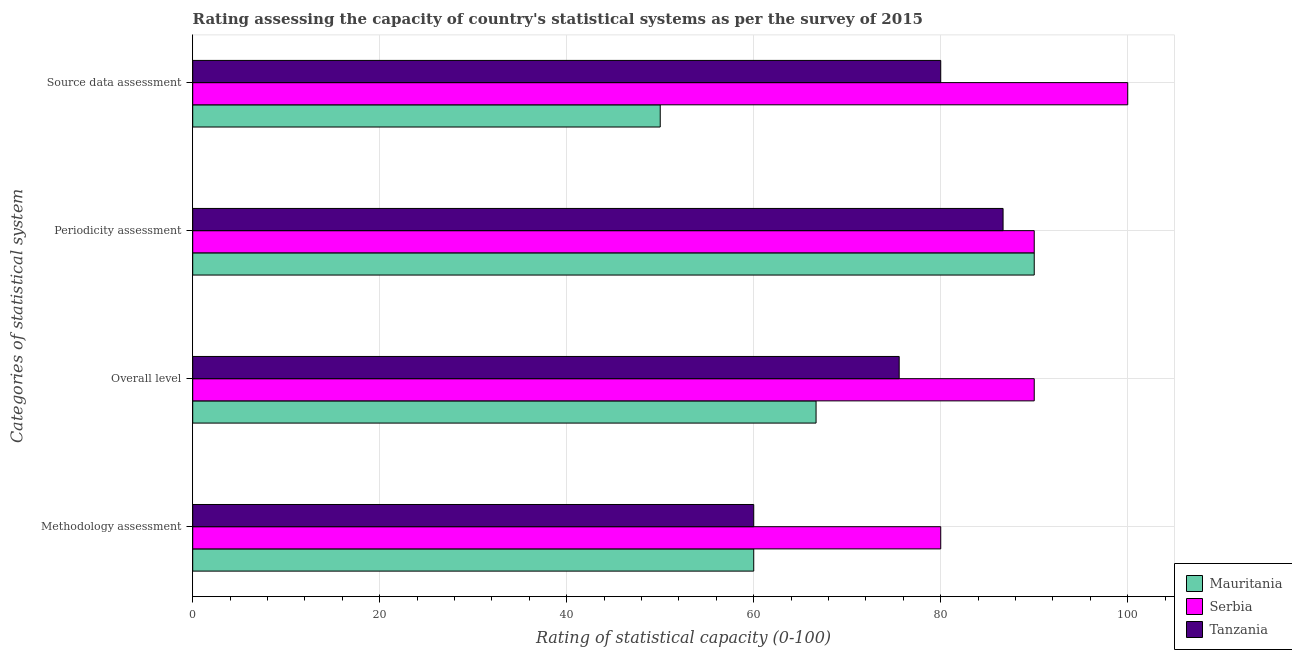How many different coloured bars are there?
Ensure brevity in your answer.  3. How many groups of bars are there?
Provide a succinct answer. 4. Are the number of bars on each tick of the Y-axis equal?
Make the answer very short. Yes. How many bars are there on the 4th tick from the top?
Make the answer very short. 3. How many bars are there on the 2nd tick from the bottom?
Offer a terse response. 3. What is the label of the 3rd group of bars from the top?
Give a very brief answer. Overall level. What is the overall level rating in Tanzania?
Ensure brevity in your answer.  75.56. Across all countries, what is the minimum source data assessment rating?
Provide a short and direct response. 50. In which country was the overall level rating maximum?
Provide a succinct answer. Serbia. In which country was the periodicity assessment rating minimum?
Your response must be concise. Tanzania. What is the total periodicity assessment rating in the graph?
Keep it short and to the point. 266.67. What is the difference between the overall level rating in Serbia and that in Tanzania?
Ensure brevity in your answer.  14.44. What is the average overall level rating per country?
Your response must be concise. 77.41. What is the difference between the overall level rating and source data assessment rating in Mauritania?
Ensure brevity in your answer.  16.67. In how many countries, is the source data assessment rating greater than 28 ?
Ensure brevity in your answer.  3. Is the methodology assessment rating in Serbia less than that in Tanzania?
Give a very brief answer. No. Is the difference between the periodicity assessment rating in Tanzania and Mauritania greater than the difference between the methodology assessment rating in Tanzania and Mauritania?
Make the answer very short. No. What is the difference between the highest and the lowest overall level rating?
Your answer should be very brief. 23.33. In how many countries, is the overall level rating greater than the average overall level rating taken over all countries?
Your answer should be very brief. 1. Is the sum of the source data assessment rating in Mauritania and Tanzania greater than the maximum methodology assessment rating across all countries?
Your response must be concise. Yes. Is it the case that in every country, the sum of the periodicity assessment rating and overall level rating is greater than the sum of methodology assessment rating and source data assessment rating?
Your answer should be compact. Yes. What does the 2nd bar from the top in Periodicity assessment represents?
Give a very brief answer. Serbia. What does the 1st bar from the bottom in Overall level represents?
Your answer should be very brief. Mauritania. How many bars are there?
Make the answer very short. 12. Are all the bars in the graph horizontal?
Ensure brevity in your answer.  Yes. Are the values on the major ticks of X-axis written in scientific E-notation?
Your response must be concise. No. Does the graph contain grids?
Provide a succinct answer. Yes. Where does the legend appear in the graph?
Offer a terse response. Bottom right. How many legend labels are there?
Make the answer very short. 3. What is the title of the graph?
Provide a succinct answer. Rating assessing the capacity of country's statistical systems as per the survey of 2015 . Does "Turkmenistan" appear as one of the legend labels in the graph?
Ensure brevity in your answer.  No. What is the label or title of the X-axis?
Provide a short and direct response. Rating of statistical capacity (0-100). What is the label or title of the Y-axis?
Your answer should be very brief. Categories of statistical system. What is the Rating of statistical capacity (0-100) of Mauritania in Methodology assessment?
Ensure brevity in your answer.  60. What is the Rating of statistical capacity (0-100) of Mauritania in Overall level?
Ensure brevity in your answer.  66.67. What is the Rating of statistical capacity (0-100) of Tanzania in Overall level?
Keep it short and to the point. 75.56. What is the Rating of statistical capacity (0-100) of Mauritania in Periodicity assessment?
Provide a succinct answer. 90. What is the Rating of statistical capacity (0-100) of Serbia in Periodicity assessment?
Provide a succinct answer. 90. What is the Rating of statistical capacity (0-100) in Tanzania in Periodicity assessment?
Your answer should be compact. 86.67. What is the Rating of statistical capacity (0-100) in Mauritania in Source data assessment?
Provide a succinct answer. 50. What is the Rating of statistical capacity (0-100) of Serbia in Source data assessment?
Offer a very short reply. 100. Across all Categories of statistical system, what is the maximum Rating of statistical capacity (0-100) of Mauritania?
Ensure brevity in your answer.  90. Across all Categories of statistical system, what is the maximum Rating of statistical capacity (0-100) in Tanzania?
Provide a short and direct response. 86.67. Across all Categories of statistical system, what is the minimum Rating of statistical capacity (0-100) in Serbia?
Provide a succinct answer. 80. What is the total Rating of statistical capacity (0-100) in Mauritania in the graph?
Give a very brief answer. 266.67. What is the total Rating of statistical capacity (0-100) of Serbia in the graph?
Provide a succinct answer. 360. What is the total Rating of statistical capacity (0-100) of Tanzania in the graph?
Give a very brief answer. 302.22. What is the difference between the Rating of statistical capacity (0-100) of Mauritania in Methodology assessment and that in Overall level?
Your answer should be very brief. -6.67. What is the difference between the Rating of statistical capacity (0-100) of Serbia in Methodology assessment and that in Overall level?
Offer a very short reply. -10. What is the difference between the Rating of statistical capacity (0-100) in Tanzania in Methodology assessment and that in Overall level?
Provide a short and direct response. -15.56. What is the difference between the Rating of statistical capacity (0-100) of Mauritania in Methodology assessment and that in Periodicity assessment?
Offer a very short reply. -30. What is the difference between the Rating of statistical capacity (0-100) of Serbia in Methodology assessment and that in Periodicity assessment?
Make the answer very short. -10. What is the difference between the Rating of statistical capacity (0-100) of Tanzania in Methodology assessment and that in Periodicity assessment?
Ensure brevity in your answer.  -26.67. What is the difference between the Rating of statistical capacity (0-100) in Serbia in Methodology assessment and that in Source data assessment?
Provide a succinct answer. -20. What is the difference between the Rating of statistical capacity (0-100) of Mauritania in Overall level and that in Periodicity assessment?
Give a very brief answer. -23.33. What is the difference between the Rating of statistical capacity (0-100) in Tanzania in Overall level and that in Periodicity assessment?
Ensure brevity in your answer.  -11.11. What is the difference between the Rating of statistical capacity (0-100) of Mauritania in Overall level and that in Source data assessment?
Your answer should be very brief. 16.67. What is the difference between the Rating of statistical capacity (0-100) of Serbia in Overall level and that in Source data assessment?
Provide a succinct answer. -10. What is the difference between the Rating of statistical capacity (0-100) in Tanzania in Overall level and that in Source data assessment?
Give a very brief answer. -4.44. What is the difference between the Rating of statistical capacity (0-100) of Mauritania in Periodicity assessment and that in Source data assessment?
Give a very brief answer. 40. What is the difference between the Rating of statistical capacity (0-100) in Tanzania in Periodicity assessment and that in Source data assessment?
Give a very brief answer. 6.67. What is the difference between the Rating of statistical capacity (0-100) in Mauritania in Methodology assessment and the Rating of statistical capacity (0-100) in Serbia in Overall level?
Your response must be concise. -30. What is the difference between the Rating of statistical capacity (0-100) of Mauritania in Methodology assessment and the Rating of statistical capacity (0-100) of Tanzania in Overall level?
Ensure brevity in your answer.  -15.56. What is the difference between the Rating of statistical capacity (0-100) in Serbia in Methodology assessment and the Rating of statistical capacity (0-100) in Tanzania in Overall level?
Give a very brief answer. 4.44. What is the difference between the Rating of statistical capacity (0-100) of Mauritania in Methodology assessment and the Rating of statistical capacity (0-100) of Serbia in Periodicity assessment?
Give a very brief answer. -30. What is the difference between the Rating of statistical capacity (0-100) of Mauritania in Methodology assessment and the Rating of statistical capacity (0-100) of Tanzania in Periodicity assessment?
Provide a short and direct response. -26.67. What is the difference between the Rating of statistical capacity (0-100) of Serbia in Methodology assessment and the Rating of statistical capacity (0-100) of Tanzania in Periodicity assessment?
Offer a very short reply. -6.67. What is the difference between the Rating of statistical capacity (0-100) in Mauritania in Methodology assessment and the Rating of statistical capacity (0-100) in Serbia in Source data assessment?
Ensure brevity in your answer.  -40. What is the difference between the Rating of statistical capacity (0-100) of Mauritania in Methodology assessment and the Rating of statistical capacity (0-100) of Tanzania in Source data assessment?
Provide a short and direct response. -20. What is the difference between the Rating of statistical capacity (0-100) in Serbia in Methodology assessment and the Rating of statistical capacity (0-100) in Tanzania in Source data assessment?
Provide a short and direct response. 0. What is the difference between the Rating of statistical capacity (0-100) in Mauritania in Overall level and the Rating of statistical capacity (0-100) in Serbia in Periodicity assessment?
Your response must be concise. -23.33. What is the difference between the Rating of statistical capacity (0-100) of Mauritania in Overall level and the Rating of statistical capacity (0-100) of Tanzania in Periodicity assessment?
Keep it short and to the point. -20. What is the difference between the Rating of statistical capacity (0-100) of Serbia in Overall level and the Rating of statistical capacity (0-100) of Tanzania in Periodicity assessment?
Ensure brevity in your answer.  3.33. What is the difference between the Rating of statistical capacity (0-100) of Mauritania in Overall level and the Rating of statistical capacity (0-100) of Serbia in Source data assessment?
Offer a very short reply. -33.33. What is the difference between the Rating of statistical capacity (0-100) of Mauritania in Overall level and the Rating of statistical capacity (0-100) of Tanzania in Source data assessment?
Your answer should be compact. -13.33. What is the difference between the Rating of statistical capacity (0-100) of Mauritania in Periodicity assessment and the Rating of statistical capacity (0-100) of Serbia in Source data assessment?
Ensure brevity in your answer.  -10. What is the difference between the Rating of statistical capacity (0-100) of Mauritania in Periodicity assessment and the Rating of statistical capacity (0-100) of Tanzania in Source data assessment?
Provide a succinct answer. 10. What is the difference between the Rating of statistical capacity (0-100) in Serbia in Periodicity assessment and the Rating of statistical capacity (0-100) in Tanzania in Source data assessment?
Provide a short and direct response. 10. What is the average Rating of statistical capacity (0-100) in Mauritania per Categories of statistical system?
Your answer should be compact. 66.67. What is the average Rating of statistical capacity (0-100) in Serbia per Categories of statistical system?
Keep it short and to the point. 90. What is the average Rating of statistical capacity (0-100) in Tanzania per Categories of statistical system?
Your response must be concise. 75.56. What is the difference between the Rating of statistical capacity (0-100) in Serbia and Rating of statistical capacity (0-100) in Tanzania in Methodology assessment?
Provide a succinct answer. 20. What is the difference between the Rating of statistical capacity (0-100) of Mauritania and Rating of statistical capacity (0-100) of Serbia in Overall level?
Offer a very short reply. -23.33. What is the difference between the Rating of statistical capacity (0-100) in Mauritania and Rating of statistical capacity (0-100) in Tanzania in Overall level?
Offer a very short reply. -8.89. What is the difference between the Rating of statistical capacity (0-100) in Serbia and Rating of statistical capacity (0-100) in Tanzania in Overall level?
Your answer should be compact. 14.44. What is the difference between the Rating of statistical capacity (0-100) in Mauritania and Rating of statistical capacity (0-100) in Serbia in Periodicity assessment?
Your response must be concise. 0. What is the difference between the Rating of statistical capacity (0-100) of Mauritania and Rating of statistical capacity (0-100) of Tanzania in Periodicity assessment?
Your answer should be very brief. 3.33. What is the difference between the Rating of statistical capacity (0-100) of Serbia and Rating of statistical capacity (0-100) of Tanzania in Periodicity assessment?
Your answer should be very brief. 3.33. What is the difference between the Rating of statistical capacity (0-100) of Mauritania and Rating of statistical capacity (0-100) of Serbia in Source data assessment?
Ensure brevity in your answer.  -50. What is the difference between the Rating of statistical capacity (0-100) in Serbia and Rating of statistical capacity (0-100) in Tanzania in Source data assessment?
Your answer should be very brief. 20. What is the ratio of the Rating of statistical capacity (0-100) of Mauritania in Methodology assessment to that in Overall level?
Your response must be concise. 0.9. What is the ratio of the Rating of statistical capacity (0-100) in Serbia in Methodology assessment to that in Overall level?
Your answer should be compact. 0.89. What is the ratio of the Rating of statistical capacity (0-100) in Tanzania in Methodology assessment to that in Overall level?
Make the answer very short. 0.79. What is the ratio of the Rating of statistical capacity (0-100) in Serbia in Methodology assessment to that in Periodicity assessment?
Offer a very short reply. 0.89. What is the ratio of the Rating of statistical capacity (0-100) in Tanzania in Methodology assessment to that in Periodicity assessment?
Give a very brief answer. 0.69. What is the ratio of the Rating of statistical capacity (0-100) in Serbia in Methodology assessment to that in Source data assessment?
Offer a very short reply. 0.8. What is the ratio of the Rating of statistical capacity (0-100) in Mauritania in Overall level to that in Periodicity assessment?
Your answer should be very brief. 0.74. What is the ratio of the Rating of statistical capacity (0-100) in Serbia in Overall level to that in Periodicity assessment?
Your answer should be compact. 1. What is the ratio of the Rating of statistical capacity (0-100) of Tanzania in Overall level to that in Periodicity assessment?
Keep it short and to the point. 0.87. What is the ratio of the Rating of statistical capacity (0-100) of Mauritania in Periodicity assessment to that in Source data assessment?
Give a very brief answer. 1.8. What is the ratio of the Rating of statistical capacity (0-100) of Serbia in Periodicity assessment to that in Source data assessment?
Make the answer very short. 0.9. What is the difference between the highest and the second highest Rating of statistical capacity (0-100) of Mauritania?
Offer a terse response. 23.33. What is the difference between the highest and the second highest Rating of statistical capacity (0-100) of Tanzania?
Ensure brevity in your answer.  6.67. What is the difference between the highest and the lowest Rating of statistical capacity (0-100) in Mauritania?
Provide a short and direct response. 40. What is the difference between the highest and the lowest Rating of statistical capacity (0-100) of Tanzania?
Give a very brief answer. 26.67. 